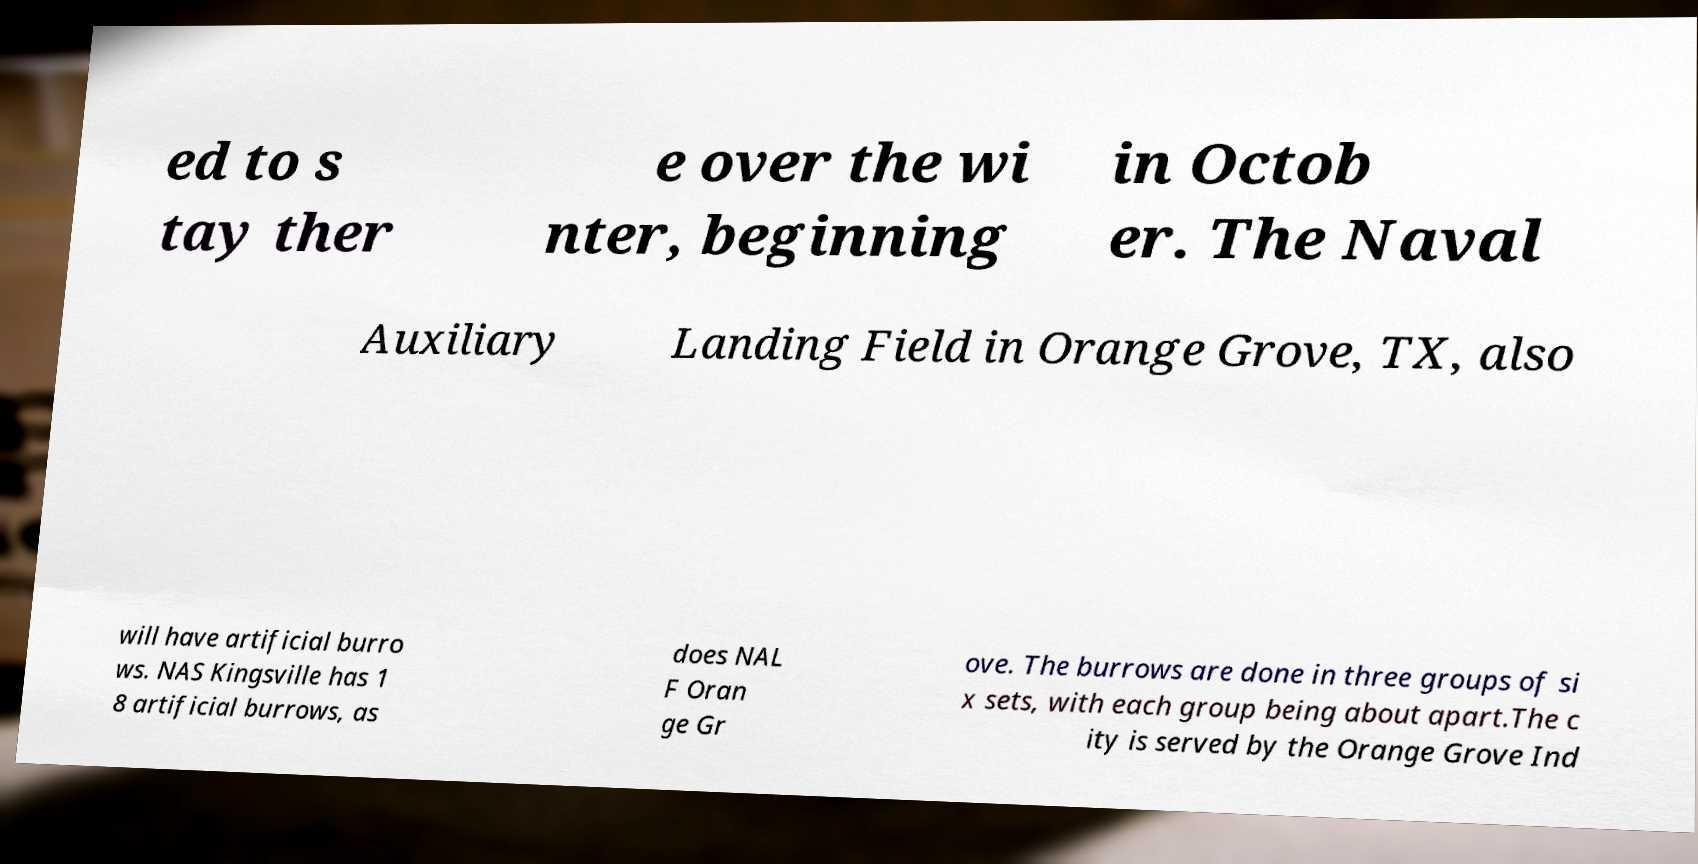For documentation purposes, I need the text within this image transcribed. Could you provide that? ed to s tay ther e over the wi nter, beginning in Octob er. The Naval Auxiliary Landing Field in Orange Grove, TX, also will have artificial burro ws. NAS Kingsville has 1 8 artificial burrows, as does NAL F Oran ge Gr ove. The burrows are done in three groups of si x sets, with each group being about apart.The c ity is served by the Orange Grove Ind 